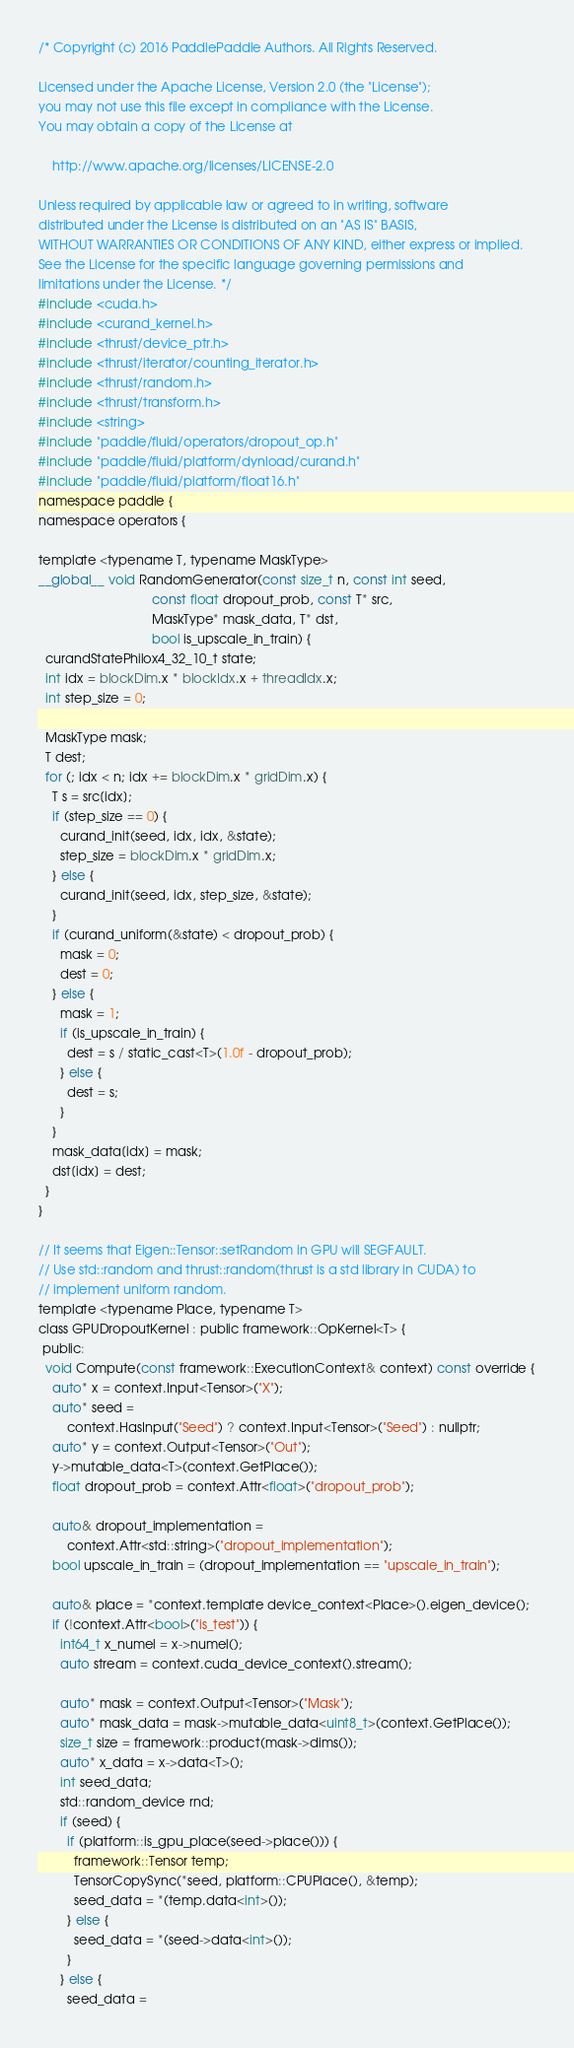Convert code to text. <code><loc_0><loc_0><loc_500><loc_500><_Cuda_>/* Copyright (c) 2016 PaddlePaddle Authors. All Rights Reserved.

Licensed under the Apache License, Version 2.0 (the "License");
you may not use this file except in compliance with the License.
You may obtain a copy of the License at

    http://www.apache.org/licenses/LICENSE-2.0

Unless required by applicable law or agreed to in writing, software
distributed under the License is distributed on an "AS IS" BASIS,
WITHOUT WARRANTIES OR CONDITIONS OF ANY KIND, either express or implied.
See the License for the specific language governing permissions and
limitations under the License. */
#include <cuda.h>
#include <curand_kernel.h>
#include <thrust/device_ptr.h>
#include <thrust/iterator/counting_iterator.h>
#include <thrust/random.h>
#include <thrust/transform.h>
#include <string>
#include "paddle/fluid/operators/dropout_op.h"
#include "paddle/fluid/platform/dynload/curand.h"
#include "paddle/fluid/platform/float16.h"
namespace paddle {
namespace operators {

template <typename T, typename MaskType>
__global__ void RandomGenerator(const size_t n, const int seed,
                                const float dropout_prob, const T* src,
                                MaskType* mask_data, T* dst,
                                bool is_upscale_in_train) {
  curandStatePhilox4_32_10_t state;
  int idx = blockDim.x * blockIdx.x + threadIdx.x;
  int step_size = 0;

  MaskType mask;
  T dest;
  for (; idx < n; idx += blockDim.x * gridDim.x) {
    T s = src[idx];
    if (step_size == 0) {
      curand_init(seed, idx, idx, &state);
      step_size = blockDim.x * gridDim.x;
    } else {
      curand_init(seed, idx, step_size, &state);
    }
    if (curand_uniform(&state) < dropout_prob) {
      mask = 0;
      dest = 0;
    } else {
      mask = 1;
      if (is_upscale_in_train) {
        dest = s / static_cast<T>(1.0f - dropout_prob);
      } else {
        dest = s;
      }
    }
    mask_data[idx] = mask;
    dst[idx] = dest;
  }
}

// It seems that Eigen::Tensor::setRandom in GPU will SEGFAULT.
// Use std::random and thrust::random(thrust is a std library in CUDA) to
// implement uniform random.
template <typename Place, typename T>
class GPUDropoutKernel : public framework::OpKernel<T> {
 public:
  void Compute(const framework::ExecutionContext& context) const override {
    auto* x = context.Input<Tensor>("X");
    auto* seed =
        context.HasInput("Seed") ? context.Input<Tensor>("Seed") : nullptr;
    auto* y = context.Output<Tensor>("Out");
    y->mutable_data<T>(context.GetPlace());
    float dropout_prob = context.Attr<float>("dropout_prob");

    auto& dropout_implementation =
        context.Attr<std::string>("dropout_implementation");
    bool upscale_in_train = (dropout_implementation == "upscale_in_train");

    auto& place = *context.template device_context<Place>().eigen_device();
    if (!context.Attr<bool>("is_test")) {
      int64_t x_numel = x->numel();
      auto stream = context.cuda_device_context().stream();

      auto* mask = context.Output<Tensor>("Mask");
      auto* mask_data = mask->mutable_data<uint8_t>(context.GetPlace());
      size_t size = framework::product(mask->dims());
      auto* x_data = x->data<T>();
      int seed_data;
      std::random_device rnd;
      if (seed) {
        if (platform::is_gpu_place(seed->place())) {
          framework::Tensor temp;
          TensorCopySync(*seed, platform::CPUPlace(), &temp);
          seed_data = *(temp.data<int>());
        } else {
          seed_data = *(seed->data<int>());
        }
      } else {
        seed_data =</code> 